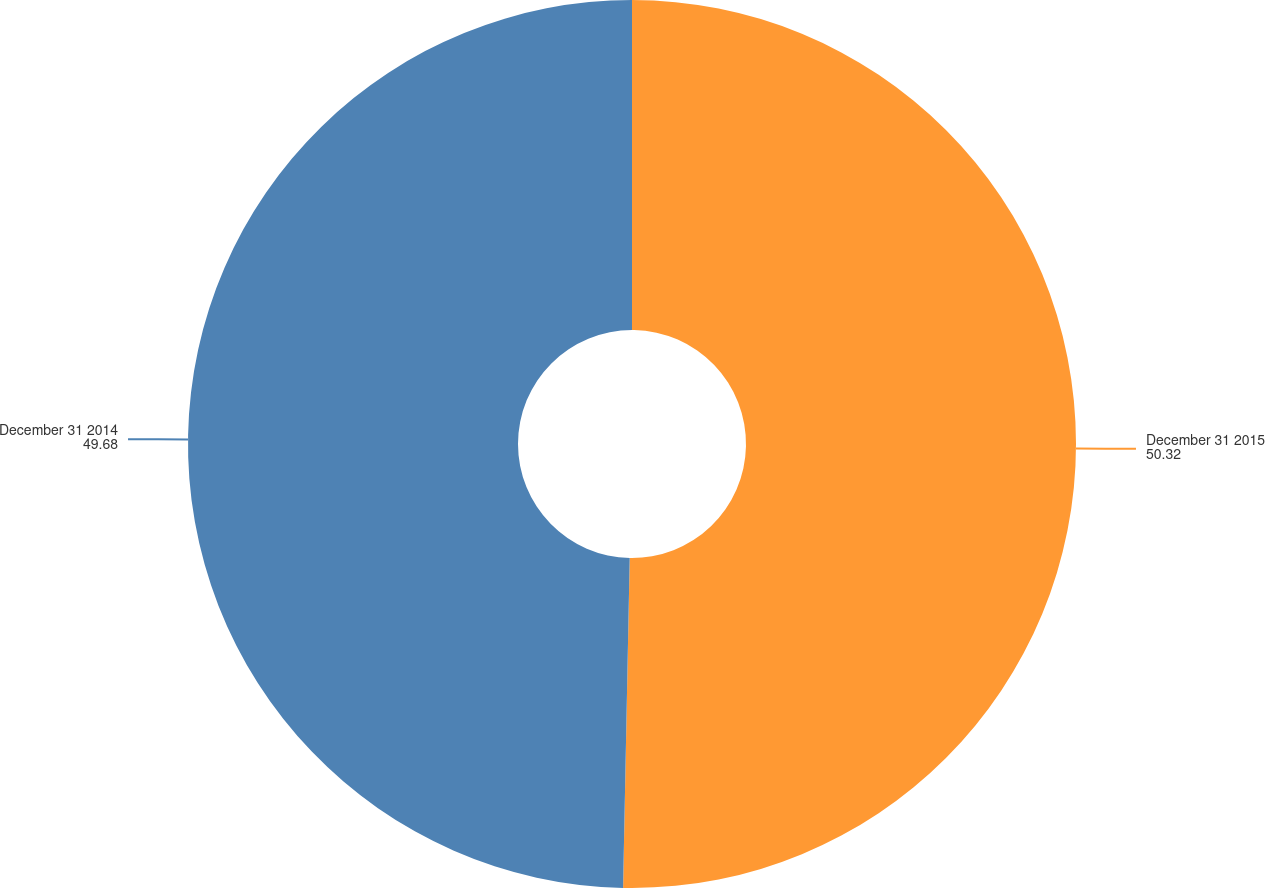<chart> <loc_0><loc_0><loc_500><loc_500><pie_chart><fcel>December 31 2015<fcel>December 31 2014<nl><fcel>50.32%<fcel>49.68%<nl></chart> 